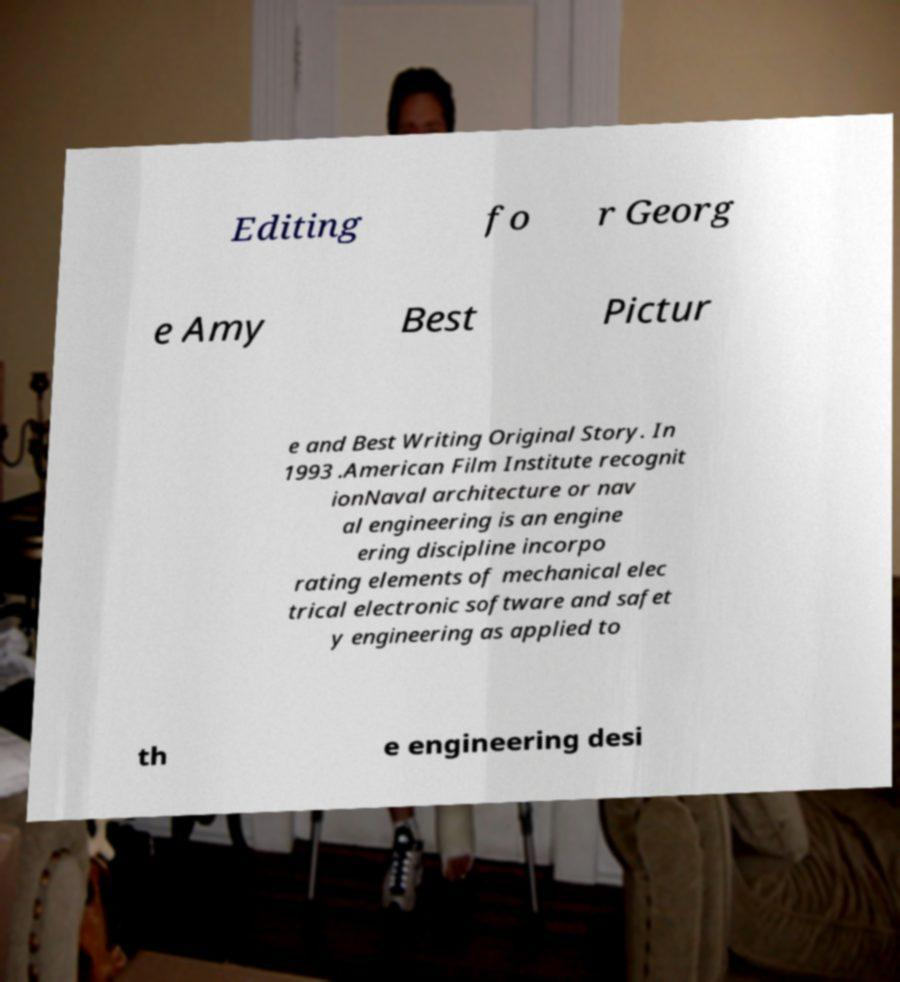Could you assist in decoding the text presented in this image and type it out clearly? Editing fo r Georg e Amy Best Pictur e and Best Writing Original Story. In 1993 .American Film Institute recognit ionNaval architecture or nav al engineering is an engine ering discipline incorpo rating elements of mechanical elec trical electronic software and safet y engineering as applied to th e engineering desi 